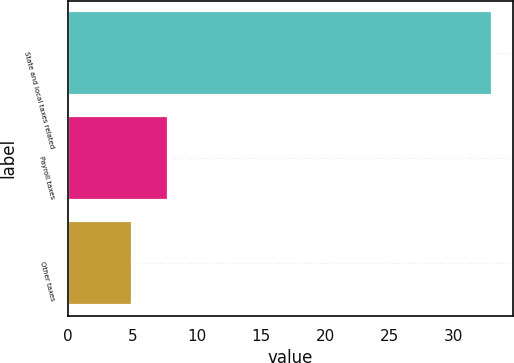<chart> <loc_0><loc_0><loc_500><loc_500><bar_chart><fcel>State and local taxes related<fcel>Payroll taxes<fcel>Other taxes<nl><fcel>33<fcel>7.8<fcel>5<nl></chart> 